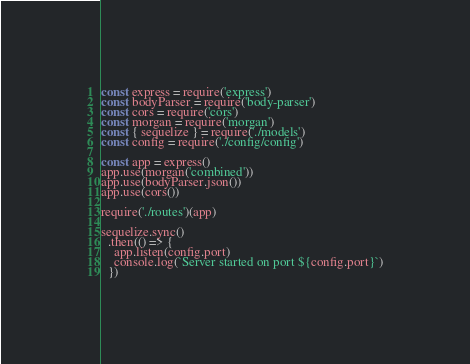<code> <loc_0><loc_0><loc_500><loc_500><_JavaScript_>const express = require('express')
const bodyParser = require('body-parser')
const cors = require('cors')
const morgan = require('morgan')
const { sequelize } = require('./models')
const config = require('./config/config')

const app = express()
app.use(morgan('combined'))
app.use(bodyParser.json())
app.use(cors())

require('./routes')(app)

sequelize.sync()
  .then(() => {
    app.listen(config.port)
    console.log(`Server started on port ${config.port}`)
  })
</code> 